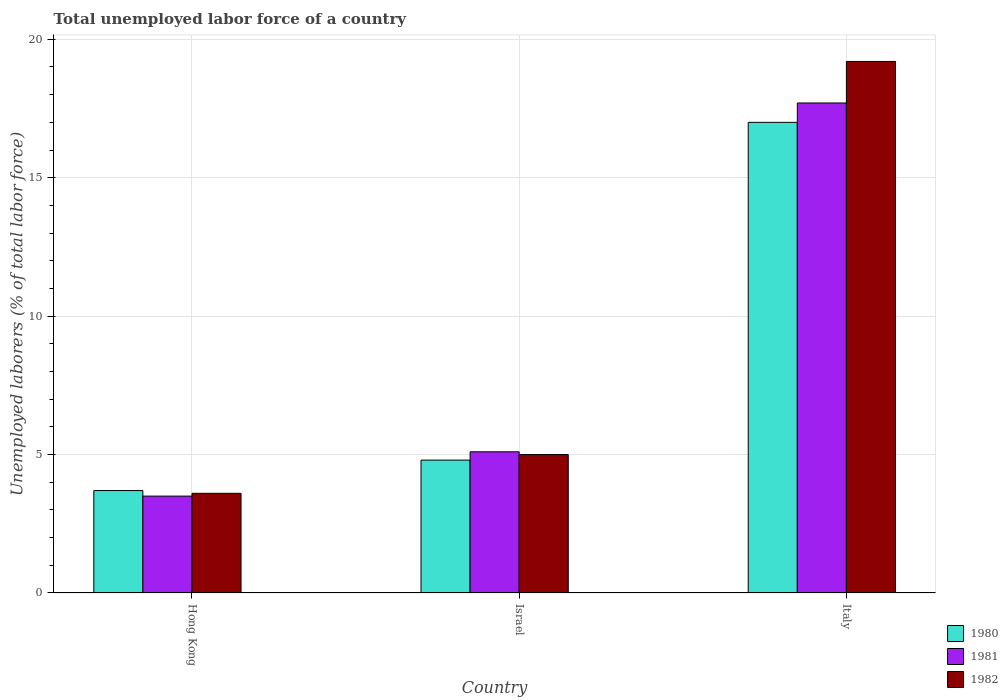How many different coloured bars are there?
Your answer should be compact. 3. How many groups of bars are there?
Make the answer very short. 3. Are the number of bars per tick equal to the number of legend labels?
Keep it short and to the point. Yes. How many bars are there on the 2nd tick from the right?
Offer a very short reply. 3. In how many cases, is the number of bars for a given country not equal to the number of legend labels?
Give a very brief answer. 0. Across all countries, what is the maximum total unemployed labor force in 1982?
Give a very brief answer. 19.2. Across all countries, what is the minimum total unemployed labor force in 1982?
Offer a very short reply. 3.6. In which country was the total unemployed labor force in 1980 minimum?
Your answer should be very brief. Hong Kong. What is the total total unemployed labor force in 1981 in the graph?
Keep it short and to the point. 26.3. What is the difference between the total unemployed labor force in 1982 in Hong Kong and that in Israel?
Your answer should be compact. -1.4. What is the difference between the total unemployed labor force in 1980 in Israel and the total unemployed labor force in 1981 in Italy?
Your answer should be very brief. -12.9. What is the average total unemployed labor force in 1980 per country?
Ensure brevity in your answer.  8.5. What is the difference between the total unemployed labor force of/in 1982 and total unemployed labor force of/in 1980 in Italy?
Your answer should be very brief. 2.2. In how many countries, is the total unemployed labor force in 1981 greater than 17 %?
Offer a very short reply. 1. What is the ratio of the total unemployed labor force in 1981 in Israel to that in Italy?
Provide a succinct answer. 0.29. Is the total unemployed labor force in 1981 in Israel less than that in Italy?
Your response must be concise. Yes. What is the difference between the highest and the second highest total unemployed labor force in 1982?
Offer a very short reply. -15.6. What is the difference between the highest and the lowest total unemployed labor force in 1980?
Provide a succinct answer. 13.3. In how many countries, is the total unemployed labor force in 1980 greater than the average total unemployed labor force in 1980 taken over all countries?
Your response must be concise. 1. What does the 1st bar from the left in Italy represents?
Give a very brief answer. 1980. What does the 2nd bar from the right in Italy represents?
Your answer should be very brief. 1981. Is it the case that in every country, the sum of the total unemployed labor force in 1980 and total unemployed labor force in 1981 is greater than the total unemployed labor force in 1982?
Provide a short and direct response. Yes. Are all the bars in the graph horizontal?
Ensure brevity in your answer.  No. How many countries are there in the graph?
Your response must be concise. 3. What is the difference between two consecutive major ticks on the Y-axis?
Provide a succinct answer. 5. Are the values on the major ticks of Y-axis written in scientific E-notation?
Make the answer very short. No. Does the graph contain grids?
Ensure brevity in your answer.  Yes. Where does the legend appear in the graph?
Offer a very short reply. Bottom right. What is the title of the graph?
Make the answer very short. Total unemployed labor force of a country. Does "1970" appear as one of the legend labels in the graph?
Your answer should be very brief. No. What is the label or title of the X-axis?
Provide a short and direct response. Country. What is the label or title of the Y-axis?
Your answer should be compact. Unemployed laborers (% of total labor force). What is the Unemployed laborers (% of total labor force) of 1980 in Hong Kong?
Your response must be concise. 3.7. What is the Unemployed laborers (% of total labor force) in 1982 in Hong Kong?
Your answer should be compact. 3.6. What is the Unemployed laborers (% of total labor force) in 1980 in Israel?
Give a very brief answer. 4.8. What is the Unemployed laborers (% of total labor force) in 1981 in Israel?
Offer a terse response. 5.1. What is the Unemployed laborers (% of total labor force) in 1982 in Israel?
Ensure brevity in your answer.  5. What is the Unemployed laborers (% of total labor force) in 1980 in Italy?
Your answer should be compact. 17. What is the Unemployed laborers (% of total labor force) of 1981 in Italy?
Give a very brief answer. 17.7. What is the Unemployed laborers (% of total labor force) in 1982 in Italy?
Your answer should be very brief. 19.2. Across all countries, what is the maximum Unemployed laborers (% of total labor force) in 1980?
Keep it short and to the point. 17. Across all countries, what is the maximum Unemployed laborers (% of total labor force) of 1981?
Make the answer very short. 17.7. Across all countries, what is the maximum Unemployed laborers (% of total labor force) of 1982?
Keep it short and to the point. 19.2. Across all countries, what is the minimum Unemployed laborers (% of total labor force) of 1980?
Your answer should be very brief. 3.7. Across all countries, what is the minimum Unemployed laborers (% of total labor force) in 1981?
Offer a terse response. 3.5. Across all countries, what is the minimum Unemployed laborers (% of total labor force) in 1982?
Provide a succinct answer. 3.6. What is the total Unemployed laborers (% of total labor force) in 1981 in the graph?
Ensure brevity in your answer.  26.3. What is the total Unemployed laborers (% of total labor force) in 1982 in the graph?
Ensure brevity in your answer.  27.8. What is the difference between the Unemployed laborers (% of total labor force) in 1980 in Hong Kong and that in Israel?
Your response must be concise. -1.1. What is the difference between the Unemployed laborers (% of total labor force) of 1982 in Hong Kong and that in Israel?
Offer a terse response. -1.4. What is the difference between the Unemployed laborers (% of total labor force) in 1980 in Hong Kong and that in Italy?
Your answer should be compact. -13.3. What is the difference between the Unemployed laborers (% of total labor force) in 1982 in Hong Kong and that in Italy?
Ensure brevity in your answer.  -15.6. What is the difference between the Unemployed laborers (% of total labor force) in 1980 in Israel and that in Italy?
Give a very brief answer. -12.2. What is the difference between the Unemployed laborers (% of total labor force) of 1981 in Israel and that in Italy?
Offer a very short reply. -12.6. What is the difference between the Unemployed laborers (% of total labor force) in 1980 in Hong Kong and the Unemployed laborers (% of total labor force) in 1982 in Italy?
Ensure brevity in your answer.  -15.5. What is the difference between the Unemployed laborers (% of total labor force) of 1981 in Hong Kong and the Unemployed laborers (% of total labor force) of 1982 in Italy?
Your answer should be very brief. -15.7. What is the difference between the Unemployed laborers (% of total labor force) of 1980 in Israel and the Unemployed laborers (% of total labor force) of 1982 in Italy?
Give a very brief answer. -14.4. What is the difference between the Unemployed laborers (% of total labor force) of 1981 in Israel and the Unemployed laborers (% of total labor force) of 1982 in Italy?
Offer a terse response. -14.1. What is the average Unemployed laborers (% of total labor force) of 1981 per country?
Provide a succinct answer. 8.77. What is the average Unemployed laborers (% of total labor force) of 1982 per country?
Offer a very short reply. 9.27. What is the difference between the Unemployed laborers (% of total labor force) of 1980 and Unemployed laborers (% of total labor force) of 1982 in Hong Kong?
Ensure brevity in your answer.  0.1. What is the difference between the Unemployed laborers (% of total labor force) of 1981 and Unemployed laborers (% of total labor force) of 1982 in Hong Kong?
Your answer should be compact. -0.1. What is the difference between the Unemployed laborers (% of total labor force) in 1981 and Unemployed laborers (% of total labor force) in 1982 in Israel?
Make the answer very short. 0.1. What is the difference between the Unemployed laborers (% of total labor force) of 1981 and Unemployed laborers (% of total labor force) of 1982 in Italy?
Your response must be concise. -1.5. What is the ratio of the Unemployed laborers (% of total labor force) in 1980 in Hong Kong to that in Israel?
Provide a succinct answer. 0.77. What is the ratio of the Unemployed laborers (% of total labor force) in 1981 in Hong Kong to that in Israel?
Keep it short and to the point. 0.69. What is the ratio of the Unemployed laborers (% of total labor force) of 1982 in Hong Kong to that in Israel?
Keep it short and to the point. 0.72. What is the ratio of the Unemployed laborers (% of total labor force) in 1980 in Hong Kong to that in Italy?
Your answer should be compact. 0.22. What is the ratio of the Unemployed laborers (% of total labor force) in 1981 in Hong Kong to that in Italy?
Provide a short and direct response. 0.2. What is the ratio of the Unemployed laborers (% of total labor force) of 1982 in Hong Kong to that in Italy?
Your answer should be compact. 0.19. What is the ratio of the Unemployed laborers (% of total labor force) in 1980 in Israel to that in Italy?
Your response must be concise. 0.28. What is the ratio of the Unemployed laborers (% of total labor force) of 1981 in Israel to that in Italy?
Provide a succinct answer. 0.29. What is the ratio of the Unemployed laborers (% of total labor force) in 1982 in Israel to that in Italy?
Your answer should be compact. 0.26. What is the difference between the highest and the second highest Unemployed laborers (% of total labor force) in 1982?
Your answer should be compact. 14.2. What is the difference between the highest and the lowest Unemployed laborers (% of total labor force) in 1980?
Offer a very short reply. 13.3. 